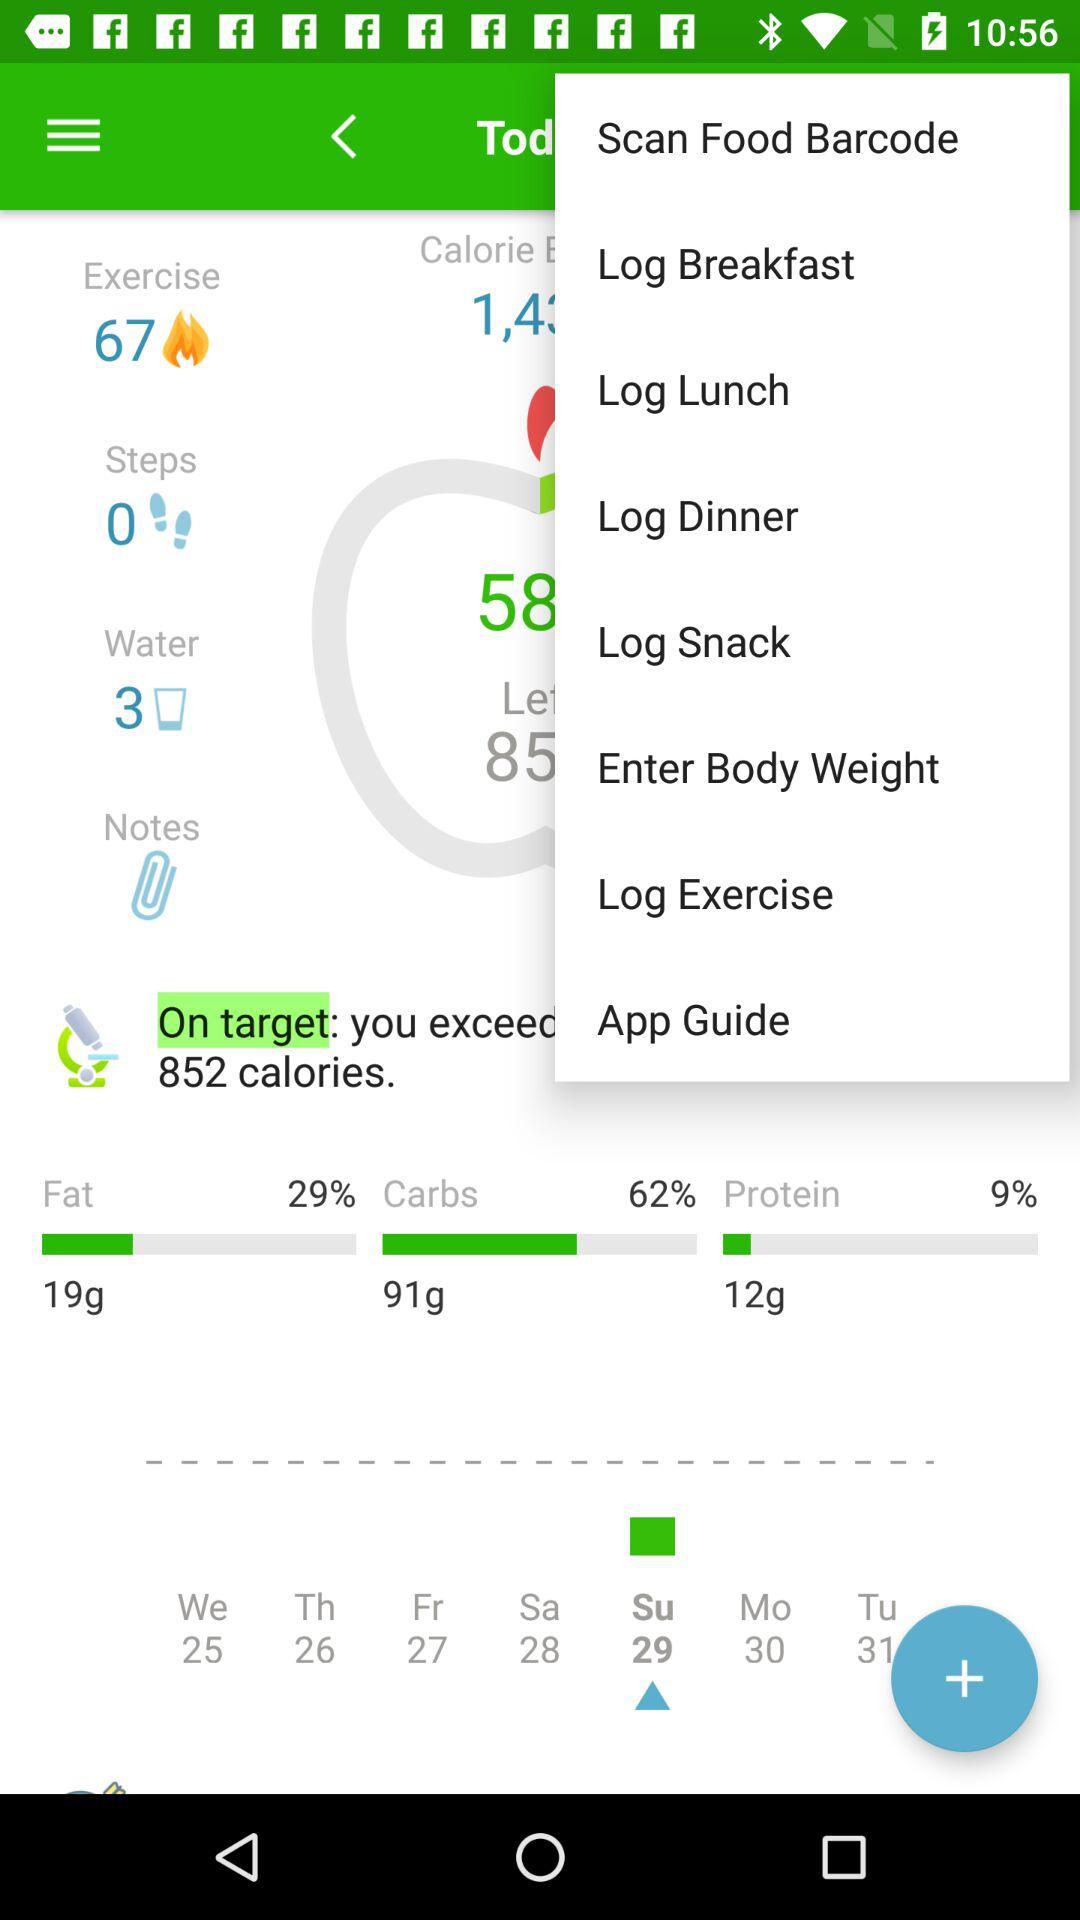How many percentages are there for fat? The percentage is 29. 